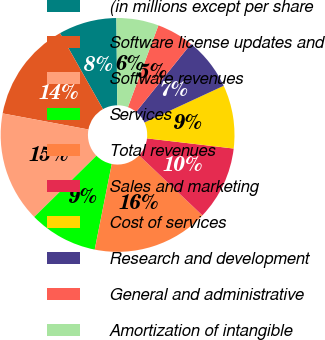Convert chart. <chart><loc_0><loc_0><loc_500><loc_500><pie_chart><fcel>(in millions except per share<fcel>Software license updates and<fcel>Software revenues<fcel>Services<fcel>Total revenues<fcel>Sales and marketing<fcel>Cost of services<fcel>Research and development<fcel>General and administrative<fcel>Amortization of intangible<nl><fcel>8.03%<fcel>13.86%<fcel>15.32%<fcel>9.49%<fcel>16.05%<fcel>10.22%<fcel>8.76%<fcel>7.3%<fcel>5.12%<fcel>5.84%<nl></chart> 